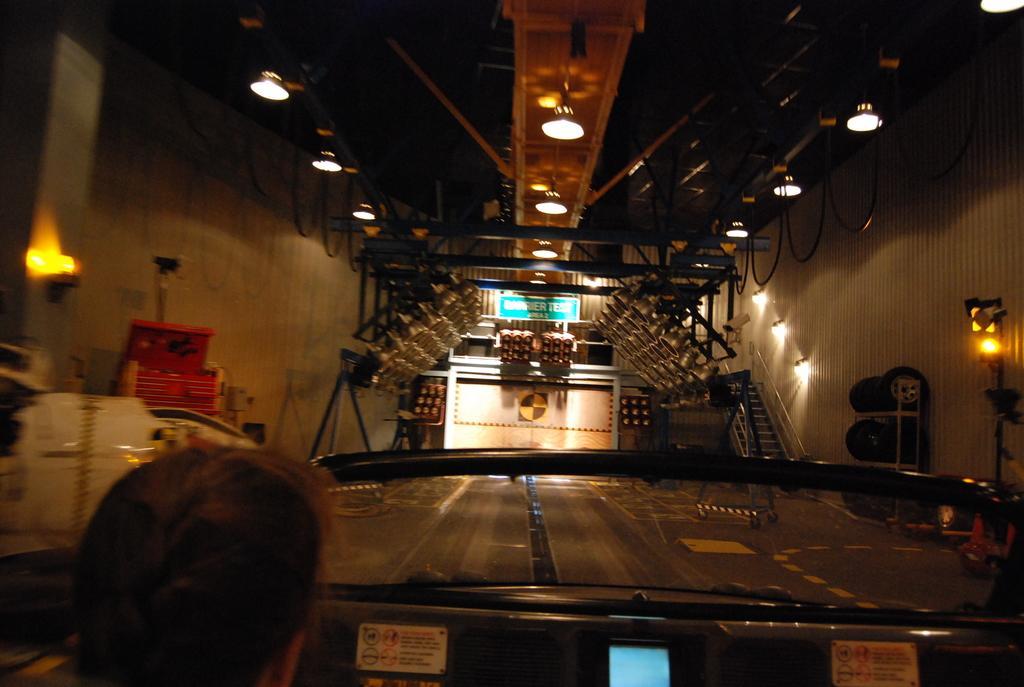Describe this image in one or two sentences. This is looking like an inside view of a shed. At the bottom of the image I can see a vehicle and a person's head. In the background there are some stairs and I can see few objects on a box and also there is a board. At the top I can see few lights to the roof. 